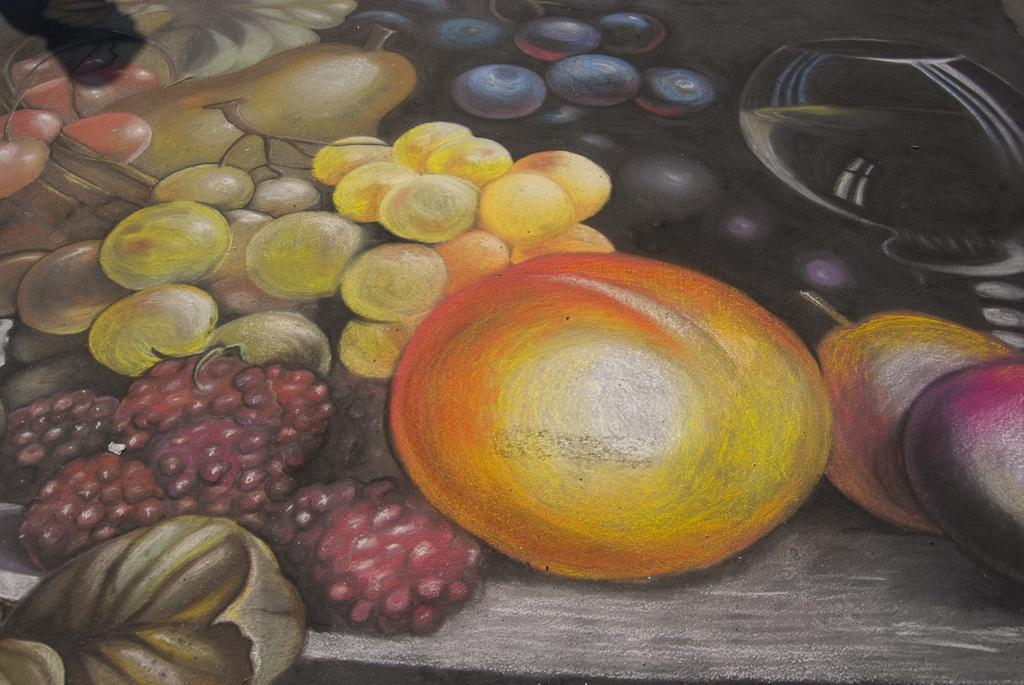What is the main subject of the image? The image contains a painting. What is the painting depicting? The painting depicts fruits. Is there a watch visible in the painting? There is no watch present in the painting; it depicts fruits. Can you see any sparks coming from the fruits in the painting? There are no sparks visible in the painting; it depicts fruits in a still, non-reactive manner. 